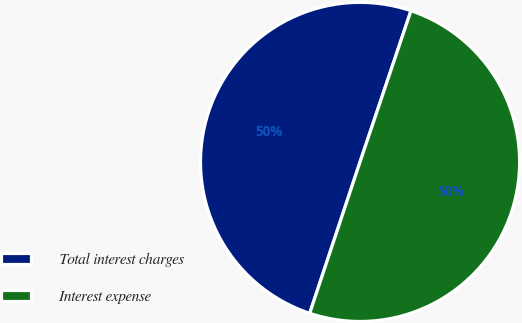Convert chart. <chart><loc_0><loc_0><loc_500><loc_500><pie_chart><fcel>Total interest charges<fcel>Interest expense<nl><fcel>50.06%<fcel>49.94%<nl></chart> 